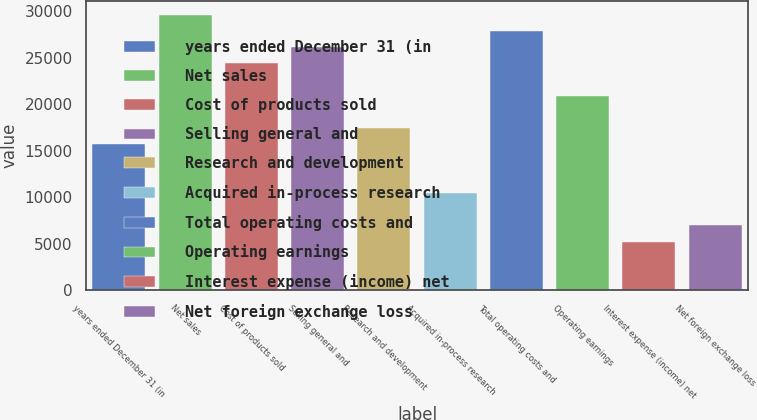Convert chart to OTSL. <chart><loc_0><loc_0><loc_500><loc_500><bar_chart><fcel>years ended December 31 (in<fcel>Net sales<fcel>Cost of products sold<fcel>Selling general and<fcel>Research and development<fcel>Acquired in-process research<fcel>Total operating costs and<fcel>Operating earnings<fcel>Interest expense (income) net<fcel>Net foreign exchange loss<nl><fcel>15699.8<fcel>29653.4<fcel>24420.8<fcel>26165<fcel>17444<fcel>10467.2<fcel>27909.2<fcel>20932.4<fcel>5234.6<fcel>6978.8<nl></chart> 